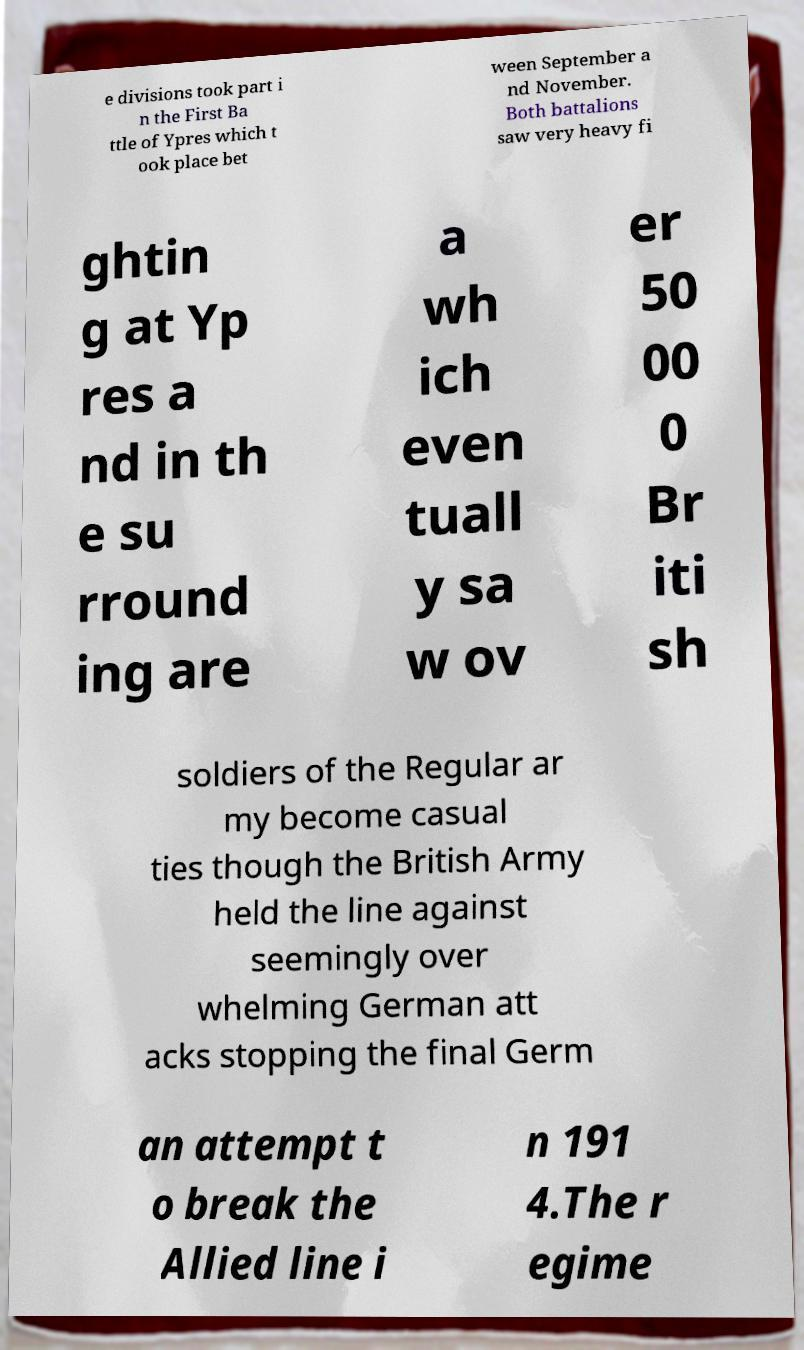Can you read and provide the text displayed in the image?This photo seems to have some interesting text. Can you extract and type it out for me? e divisions took part i n the First Ba ttle of Ypres which t ook place bet ween September a nd November. Both battalions saw very heavy fi ghtin g at Yp res a nd in th e su rround ing are a wh ich even tuall y sa w ov er 50 00 0 Br iti sh soldiers of the Regular ar my become casual ties though the British Army held the line against seemingly over whelming German att acks stopping the final Germ an attempt t o break the Allied line i n 191 4.The r egime 